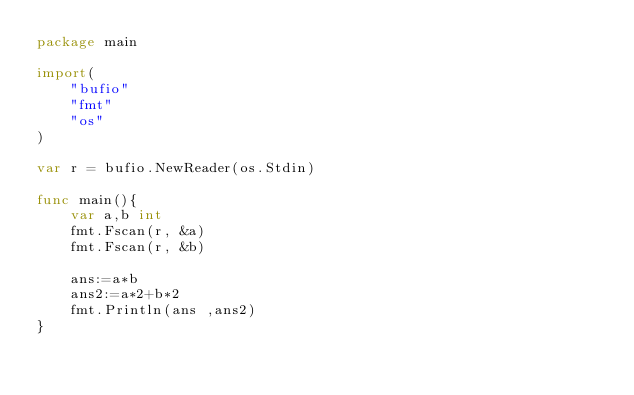<code> <loc_0><loc_0><loc_500><loc_500><_Go_>package main 

import(
    "bufio"
    "fmt"
    "os"
)

var r = bufio.NewReader(os.Stdin)

func main(){
    var a,b int
    fmt.Fscan(r, &a)
    fmt.Fscan(r, &b)
    
    ans:=a*b
    ans2:=a*2+b*2
    fmt.Println(ans ,ans2)
}

</code> 